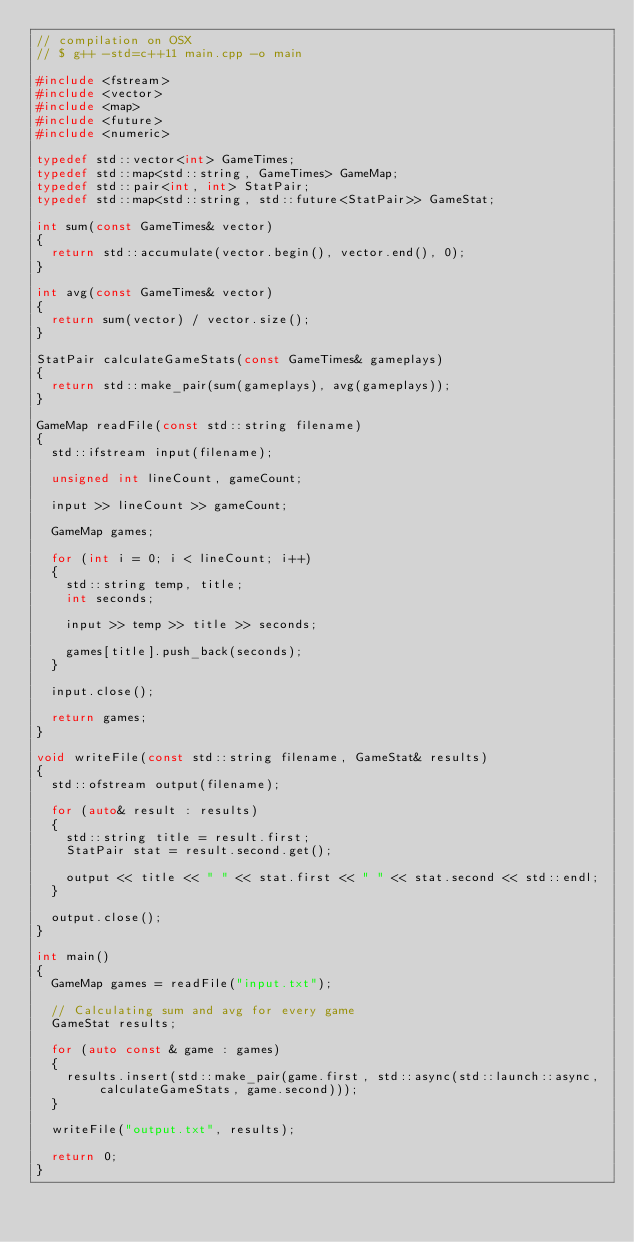<code> <loc_0><loc_0><loc_500><loc_500><_C++_>// compilation on OSX
// $ g++ -std=c++11 main.cpp -o main

#include <fstream>
#include <vector>
#include <map>
#include <future>
#include <numeric>

typedef std::vector<int> GameTimes;
typedef std::map<std::string, GameTimes> GameMap;
typedef std::pair<int, int> StatPair;
typedef std::map<std::string, std::future<StatPair>> GameStat;

int sum(const GameTimes& vector)
{
  return std::accumulate(vector.begin(), vector.end(), 0);
}

int avg(const GameTimes& vector)
{
  return sum(vector) / vector.size();
}

StatPair calculateGameStats(const GameTimes& gameplays)
{
  return std::make_pair(sum(gameplays), avg(gameplays));
}

GameMap readFile(const std::string filename)
{
  std::ifstream input(filename);

  unsigned int lineCount, gameCount;

  input >> lineCount >> gameCount;

  GameMap games;

  for (int i = 0; i < lineCount; i++)
  {
    std::string temp, title;
    int seconds;

    input >> temp >> title >> seconds;

    games[title].push_back(seconds);
  }

  input.close();

  return games;
}

void writeFile(const std::string filename, GameStat& results)
{
  std::ofstream output(filename);

  for (auto& result : results)
  {
    std::string title = result.first;
    StatPair stat = result.second.get();

    output << title << " " << stat.first << " " << stat.second << std::endl;
  }

  output.close();
}

int main()
{
  GameMap games = readFile("input.txt");

  // Calculating sum and avg for every game
  GameStat results;

  for (auto const & game : games)
  {
    results.insert(std::make_pair(game.first, std::async(std::launch::async, calculateGameStats, game.second)));
  }

  writeFile("output.txt", results);

  return 0;
}
</code> 